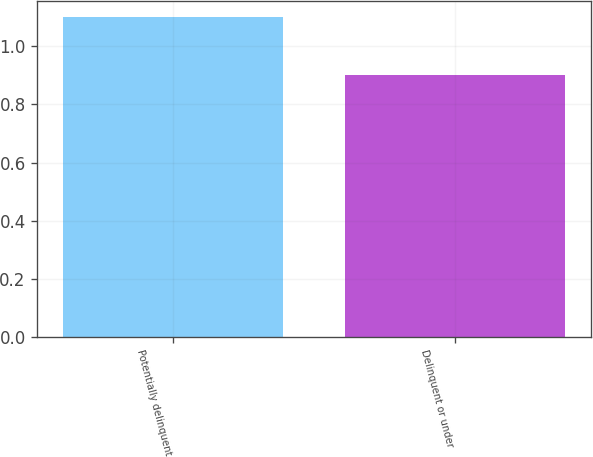<chart> <loc_0><loc_0><loc_500><loc_500><bar_chart><fcel>Potentially delinquent<fcel>Delinquent or under<nl><fcel>1.1<fcel>0.9<nl></chart> 